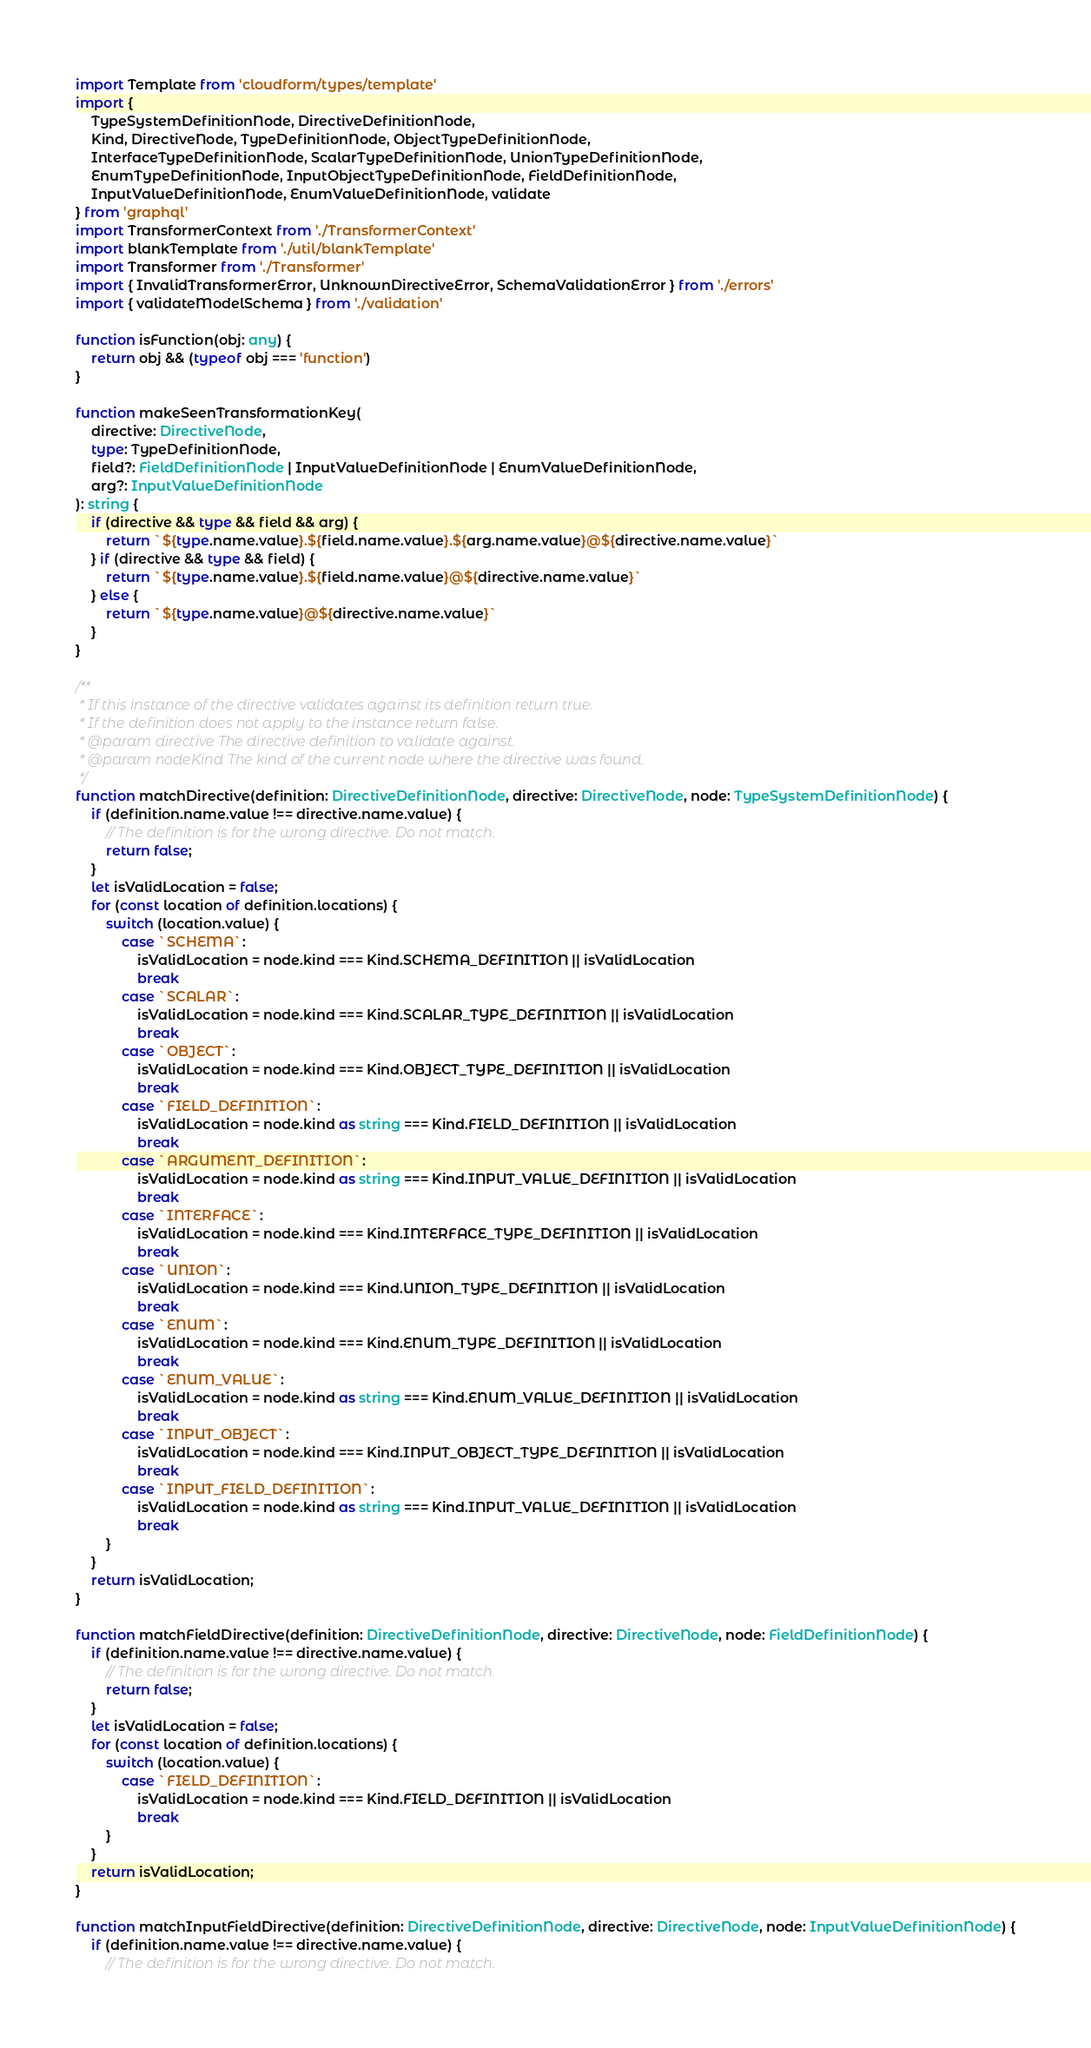<code> <loc_0><loc_0><loc_500><loc_500><_TypeScript_>import Template from 'cloudform/types/template'
import {
    TypeSystemDefinitionNode, DirectiveDefinitionNode,
    Kind, DirectiveNode, TypeDefinitionNode, ObjectTypeDefinitionNode,
    InterfaceTypeDefinitionNode, ScalarTypeDefinitionNode, UnionTypeDefinitionNode,
    EnumTypeDefinitionNode, InputObjectTypeDefinitionNode, FieldDefinitionNode,
    InputValueDefinitionNode, EnumValueDefinitionNode, validate
} from 'graphql'
import TransformerContext from './TransformerContext'
import blankTemplate from './util/blankTemplate'
import Transformer from './Transformer'
import { InvalidTransformerError, UnknownDirectiveError, SchemaValidationError } from './errors'
import { validateModelSchema } from './validation'

function isFunction(obj: any) {
    return obj && (typeof obj === 'function')
}

function makeSeenTransformationKey(
    directive: DirectiveNode,
    type: TypeDefinitionNode,
    field?: FieldDefinitionNode | InputValueDefinitionNode | EnumValueDefinitionNode,
    arg?: InputValueDefinitionNode
): string {
    if (directive && type && field && arg) {
        return `${type.name.value}.${field.name.value}.${arg.name.value}@${directive.name.value}`
    } if (directive && type && field) {
        return `${type.name.value}.${field.name.value}@${directive.name.value}`
    } else {
        return `${type.name.value}@${directive.name.value}`
    }
}

/**
 * If this instance of the directive validates against its definition return true.
 * If the definition does not apply to the instance return false.
 * @param directive The directive definition to validate against.
 * @param nodeKind The kind of the current node where the directive was found.
 */
function matchDirective(definition: DirectiveDefinitionNode, directive: DirectiveNode, node: TypeSystemDefinitionNode) {
    if (definition.name.value !== directive.name.value) {
        // The definition is for the wrong directive. Do not match.
        return false;
    }
    let isValidLocation = false;
    for (const location of definition.locations) {
        switch (location.value) {
            case `SCHEMA`:
                isValidLocation = node.kind === Kind.SCHEMA_DEFINITION || isValidLocation
                break
            case `SCALAR`:
                isValidLocation = node.kind === Kind.SCALAR_TYPE_DEFINITION || isValidLocation
                break
            case `OBJECT`:
                isValidLocation = node.kind === Kind.OBJECT_TYPE_DEFINITION || isValidLocation
                break
            case `FIELD_DEFINITION`:
                isValidLocation = node.kind as string === Kind.FIELD_DEFINITION || isValidLocation
                break
            case `ARGUMENT_DEFINITION`:
                isValidLocation = node.kind as string === Kind.INPUT_VALUE_DEFINITION || isValidLocation
                break
            case `INTERFACE`:
                isValidLocation = node.kind === Kind.INTERFACE_TYPE_DEFINITION || isValidLocation
                break
            case `UNION`:
                isValidLocation = node.kind === Kind.UNION_TYPE_DEFINITION || isValidLocation
                break
            case `ENUM`:
                isValidLocation = node.kind === Kind.ENUM_TYPE_DEFINITION || isValidLocation
                break
            case `ENUM_VALUE`:
                isValidLocation = node.kind as string === Kind.ENUM_VALUE_DEFINITION || isValidLocation
                break
            case `INPUT_OBJECT`:
                isValidLocation = node.kind === Kind.INPUT_OBJECT_TYPE_DEFINITION || isValidLocation
                break
            case `INPUT_FIELD_DEFINITION`:
                isValidLocation = node.kind as string === Kind.INPUT_VALUE_DEFINITION || isValidLocation
                break
        }
    }
    return isValidLocation;
}

function matchFieldDirective(definition: DirectiveDefinitionNode, directive: DirectiveNode, node: FieldDefinitionNode) {
    if (definition.name.value !== directive.name.value) {
        // The definition is for the wrong directive. Do not match.
        return false;
    }
    let isValidLocation = false;
    for (const location of definition.locations) {
        switch (location.value) {
            case `FIELD_DEFINITION`:
                isValidLocation = node.kind === Kind.FIELD_DEFINITION || isValidLocation
                break
        }
    }
    return isValidLocation;
}

function matchInputFieldDirective(definition: DirectiveDefinitionNode, directive: DirectiveNode, node: InputValueDefinitionNode) {
    if (definition.name.value !== directive.name.value) {
        // The definition is for the wrong directive. Do not match.</code> 